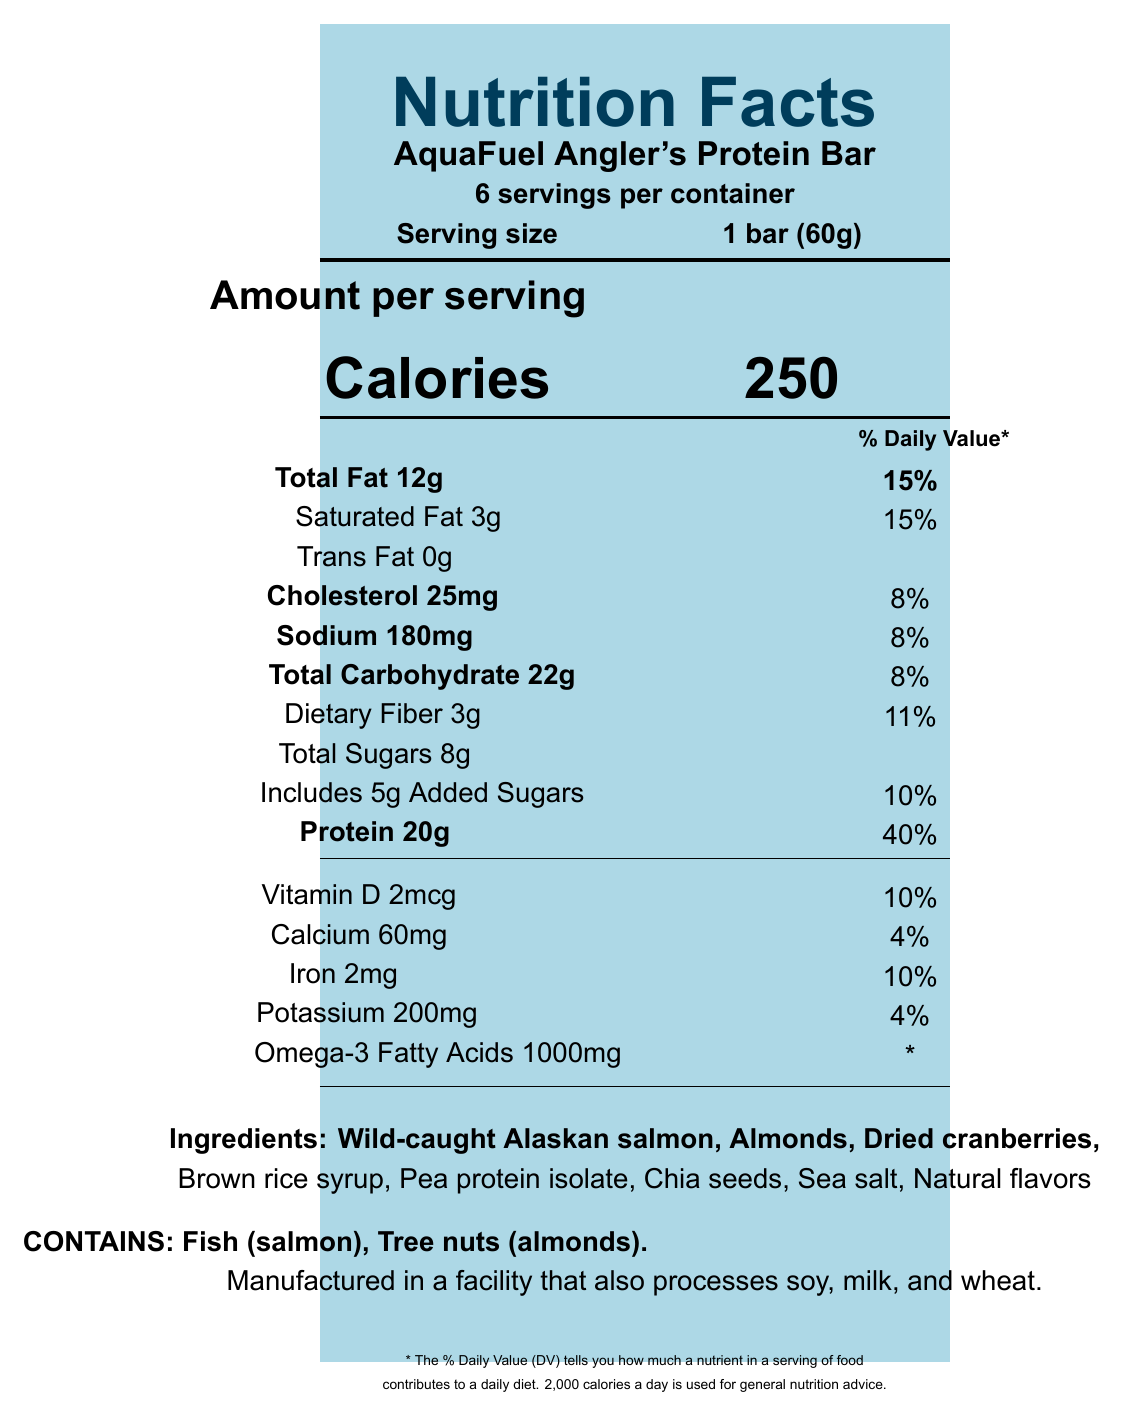what is the serving size of the AquaFuel Angler's Protein Bar? The serving size is listed in the top section of the Nutrition Facts label as "Serving size: 1 bar (60g)".
Answer: 1 bar (60g) how many servings are in one container? The label indicates "6 servings per container" near the top of the document.
Answer: 6 servings how many calories are there per serving? The "Amount per serving" section lists the calorie content clearly as "Calories 250".
Answer: 250 calories what is the amount of total fat in one serving? Under the nutrition breakdown, the label specifies "Total Fat 12g" alongside the percentage daily value.
Answer: 12g how much protein is in one serving of the bar? The nutrition label indicates "Protein 20g" with a daily value percentage of 40%.
Answer: 20g how much saturated fat is in each bar? The label shows "Saturated Fat 3g" under the Total Fat information.
Answer: 3g how many milligrams of cholesterol are present in one serving? The document notes "Cholesterol 25mg" with a daily value of 8%.
Answer: 25mg what are the main ingredients in the AquaFuel Angler's Protein Bar? The list of ingredients is provided near the bottom of the label.
Answer: Wild-caught Alaskan salmon, Almonds, Dried cranberries, Brown rice syrup, Pea protein isolate, Chia seeds, Sea salt, Natural flavors how much sodium does one serving contain? The sodium content is listed as "Sodium 180mg" with a daily value percentage of 8%.
Answer: 180mg how much dietary fiber is in the bar? The fiber content is noted as "Dietary Fiber 3g" along with the percentage daily value of 11%.
Answer: 3g which of the following ingredients is NOT in the AquaFuel Angler's Protein Bar? A) Wild-caught Alaskan salmon B) Almonds C) Soy protein isolate D) Dried cranberries The ingredient list includes Wild-caught Alaskan salmon, Almonds, Dried cranberries, but not Soy protein isolate.
Answer: C) Soy protein isolate what is the daily value percentage of iron per serving? A. 4% B. 8% C. 10% D. 15% The label indicates that the iron content per serving is 10% of the daily value.
Answer: C. 10% does the Nutrition Facts label show the amount of trans fat? The document includes the information "Trans Fat 0g" under the Total Fat section.
Answer: Yes does the protein bar contain any allergens? The label specifies: "Contains: Fish (salmon), Tree nuts (almonds)".
Answer: Yes what other foods are processed in the same facility as the AquaFuel Angler's Protein Bar? It notes: "Manufactured in a facility that also processes soy, milk, and wheat" near the bottom of the label.
Answer: Soy, milk, and wheat summarize the key information provided in the Nutrition Facts label for the AquaFuel Angler's Protein Bar. The label provides a complete view of the nutritional composition of the AquaFuel Angler's Protein Bar, along with ingredients, allergens, and manufacturing details, using visual structure and detailed breakdowns to aid understanding.
Answer: The Nutrition Facts label for AquaFuel Angler's Protein Bar details its serving size (1 bar/60g), servings per container (6), calorie content (250 calories), and breakdown of various nutrients including fats, cholesterol, sodium, carbohydrates, and protein. The label also states the presence of vitamins and minerals, mentions key ingredients, and highlights allergen information and other processing details. The daily value percentages for several nutrients are included to help consumers understand the nutritional contribution of each serving. how much omega-3 fatty acids does each bar contain? The label specifies "Omega-3 Fatty Acids 1000mg" near the vitamin and mineral information.
Answer: 1000mg what is the daily value percentage of the custom fact Astaxanthin? The percentage daily value for Astaxanthin is not given, denoted by an asterisk as "*".
Answer: Not specified what is the recommended daily caloric intake used for the daily value percentages? This information is provided at the bottom of the label, stating: "2,000 calories a day is used for general nutrition advice."
Answer: 2,000 calories how much taurine is in one bar? The custom fact for Taurine is stated as "Taurine 50mg" with an asterisk for the daily value.
Answer: 50mg 